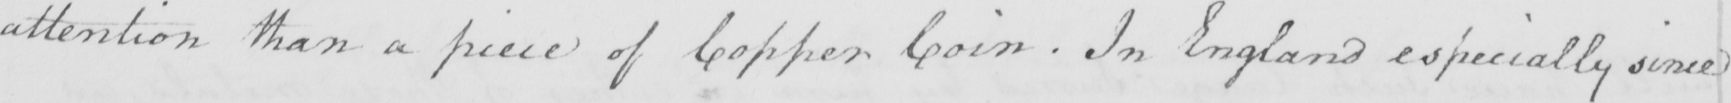Transcribe the text shown in this historical manuscript line. attention than a piece of Copper Coin . In England especially since 